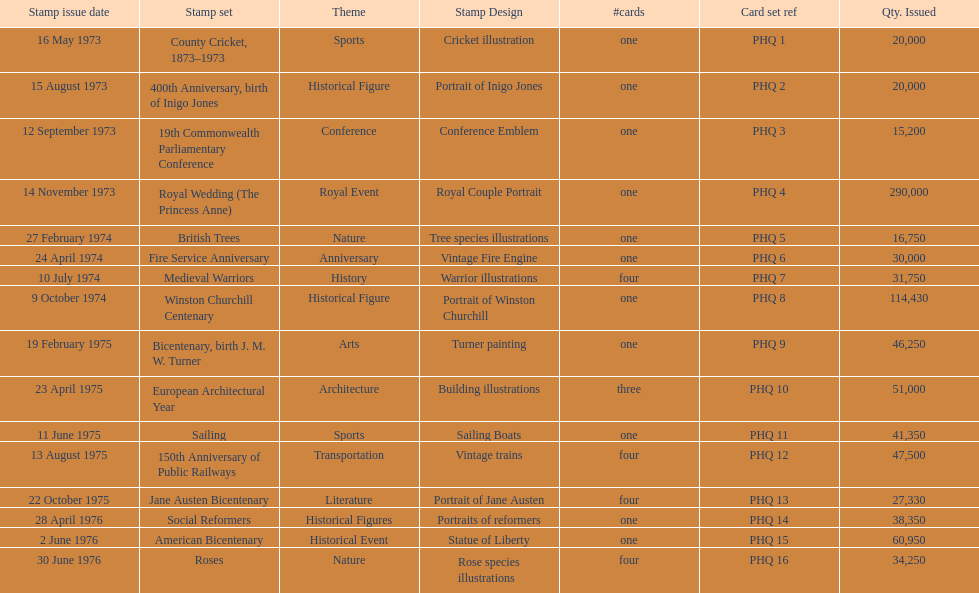Which card was given out most? Royal Wedding (The Princess Anne). 